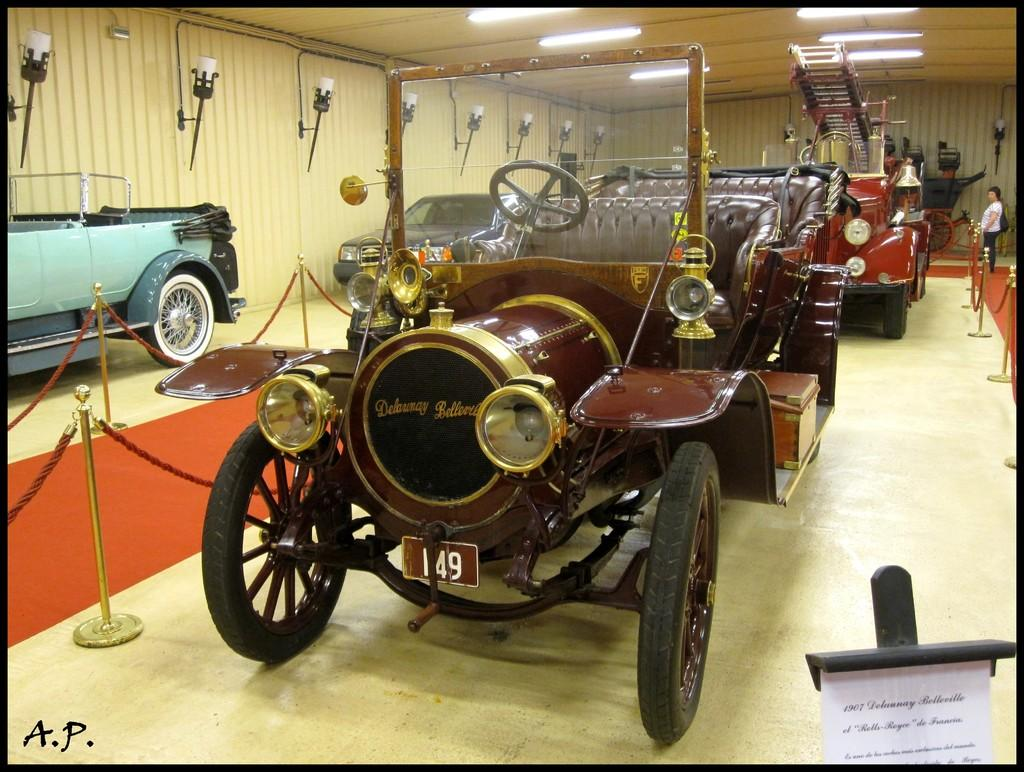What is on the floor in the image? Cars are parked on the floor in the image. What surrounds the cars in the image? Fencing is present around the cars. What is on top of the roof in the image? There are lights on top of the roof in the image. What type of hair can be seen on the cars in the image? There is no hair present on the cars in the image. How many pizzas are visible on the roof in the image? There are no pizzas present in the image; only lights are visible on the roof. 